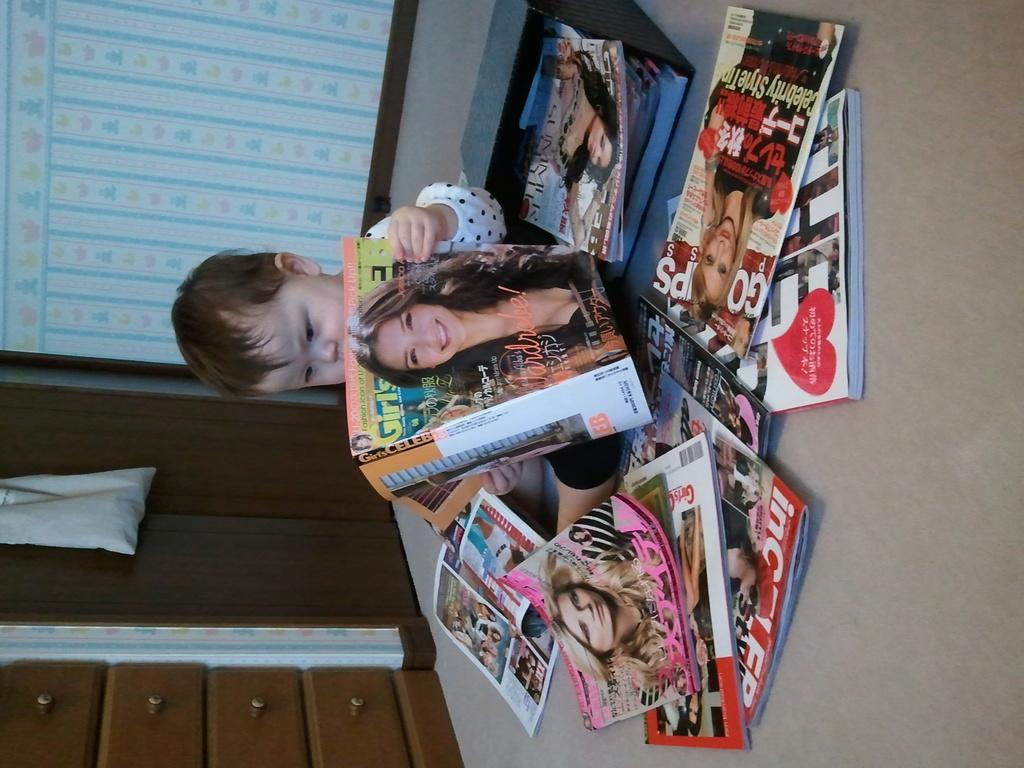What is on the floor in the image? There are many books on the floor. What is the baby doing in the image? The baby is sitting on the floor. What is the baby holding in the image? The baby is holding a book. What can be seen in the background of the image? There is a wall with a cupboard in the background. What type of stick is the baby using to read the book in the image? There is no stick present in the image; the baby is simply holding a book. How many flowers are visible in the image? There are no flowers visible in the image. 